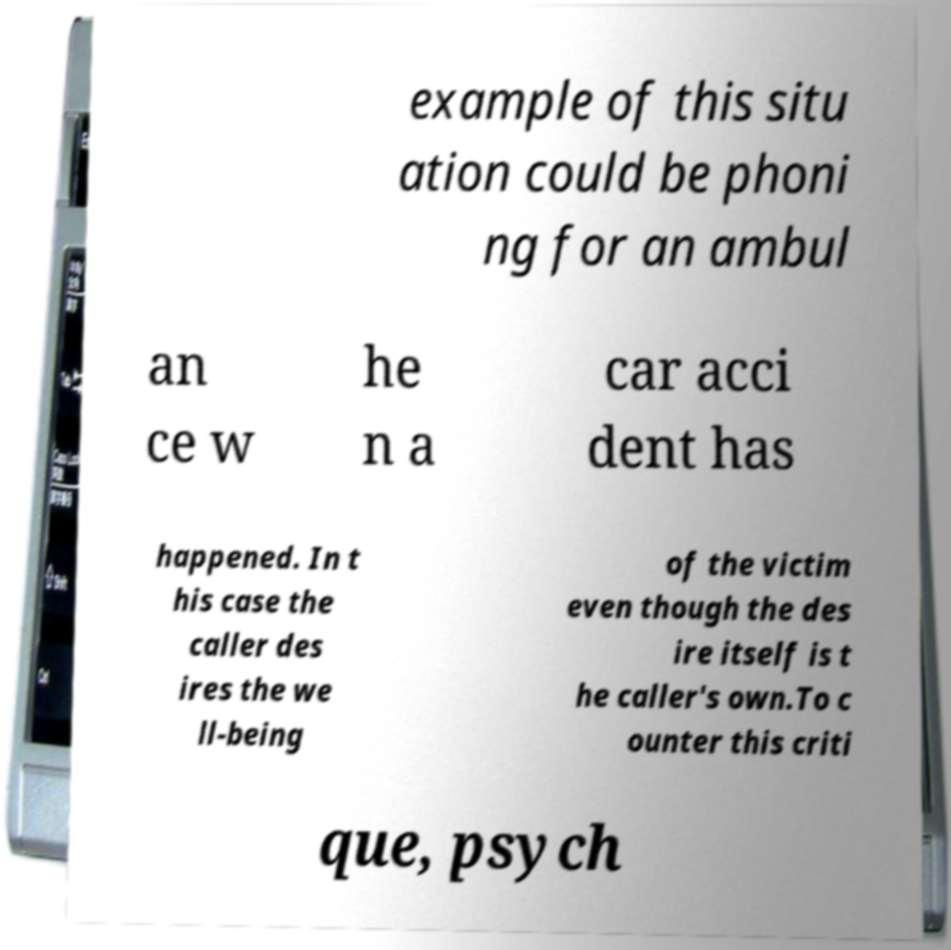What messages or text are displayed in this image? I need them in a readable, typed format. example of this situ ation could be phoni ng for an ambul an ce w he n a car acci dent has happened. In t his case the caller des ires the we ll-being of the victim even though the des ire itself is t he caller's own.To c ounter this criti que, psych 